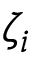Convert formula to latex. <formula><loc_0><loc_0><loc_500><loc_500>\zeta _ { i }</formula> 